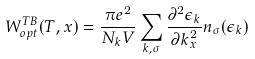<formula> <loc_0><loc_0><loc_500><loc_500>W _ { o p t } ^ { T B } ( T , x ) = \frac { \pi e ^ { 2 } } { N _ { k } V } \sum _ { { k } , \sigma } \frac { \partial ^ { 2 } \epsilon _ { k } } { \partial { k } _ { x } ^ { 2 } } n _ { \sigma } ( \epsilon _ { k } )</formula> 